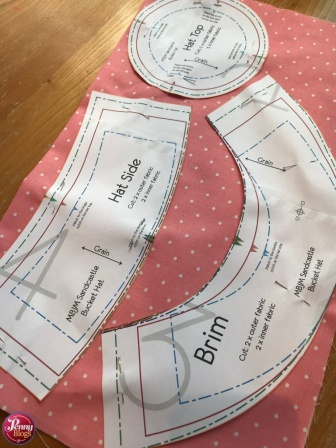What is the significance of the different patterns in the hat-making process? The different patterns each play a critical role in the hat-making process. The 'Hat Side' pattern is essential for constructing the main body of the hat, determining its circumference and fit around the head. The 'Crown' pattern provides the structure for the top of the hat, giving it shape and dimension. The 'Brim' pattern forms the outward-flaring part of the hat that can provide shade and add a stylistic element. Together, these patterns ensure that the hat is not only functional but also aesthetically pleasing. 